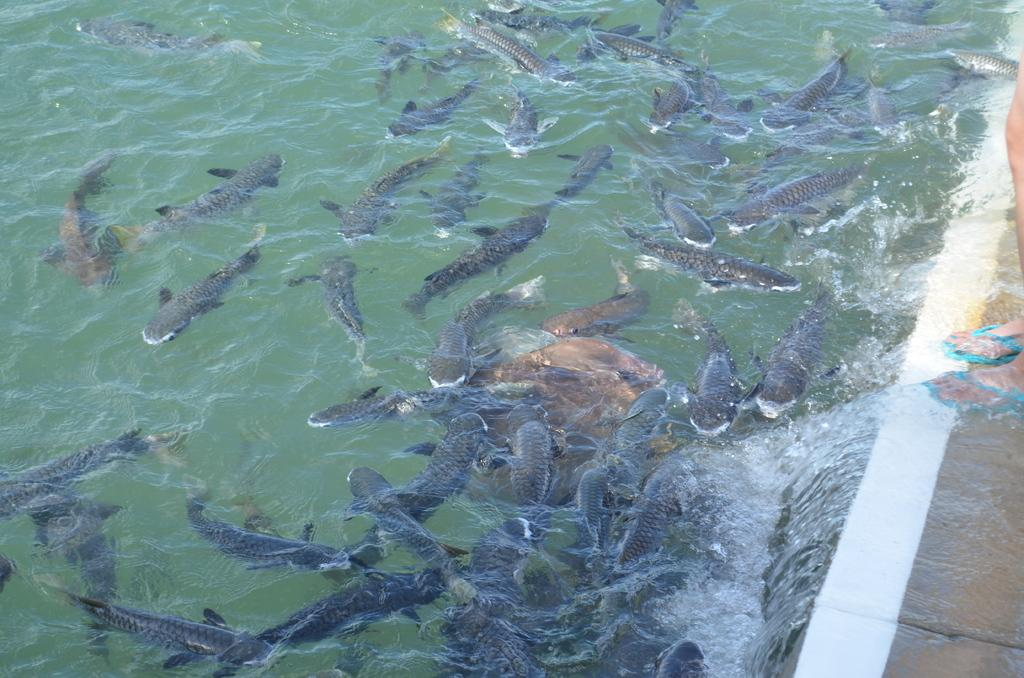What is the primary subject in the water in the image? There are many sharks in the water. Where is the person located in the image? The person is standing on the wall on the right side of the image. What type of drink is being served at the event in the image? There is no event or drink present in the image; it features sharks in the water and a person standing on a wall. What is the distance between the sharks and the earth in the image? The image does not show the sharks or the person in relation to the earth; it only shows them in the water and on the wall, respectively. 